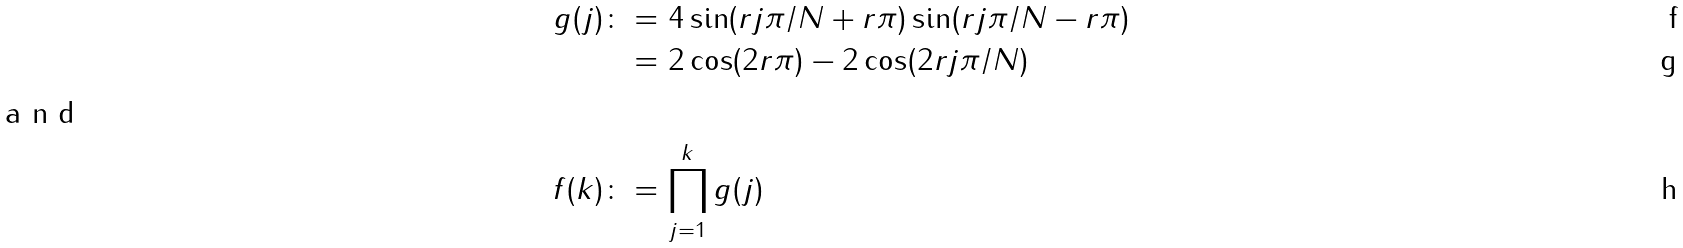Convert formula to latex. <formula><loc_0><loc_0><loc_500><loc_500>g ( j ) \colon & = 4 \sin ( r j \pi / N + r \pi ) \sin ( r j \pi / N - r \pi ) \\ & = 2 \cos ( 2 r \pi ) - 2 \cos ( 2 r j \pi / N ) \\ \intertext { a n d } f ( k ) \colon & = \prod _ { j = 1 } ^ { k } g ( j )</formula> 